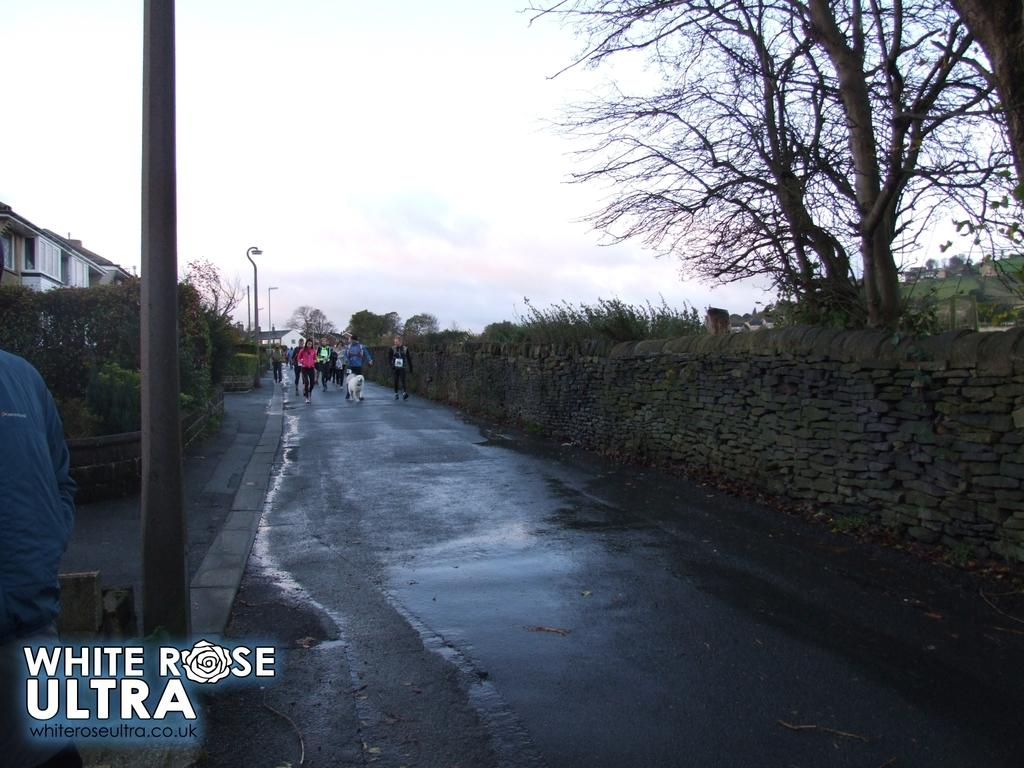<image>
Present a compact description of the photo's key features. A street scene with a naked tree and the word Ultra at the bottom left. 